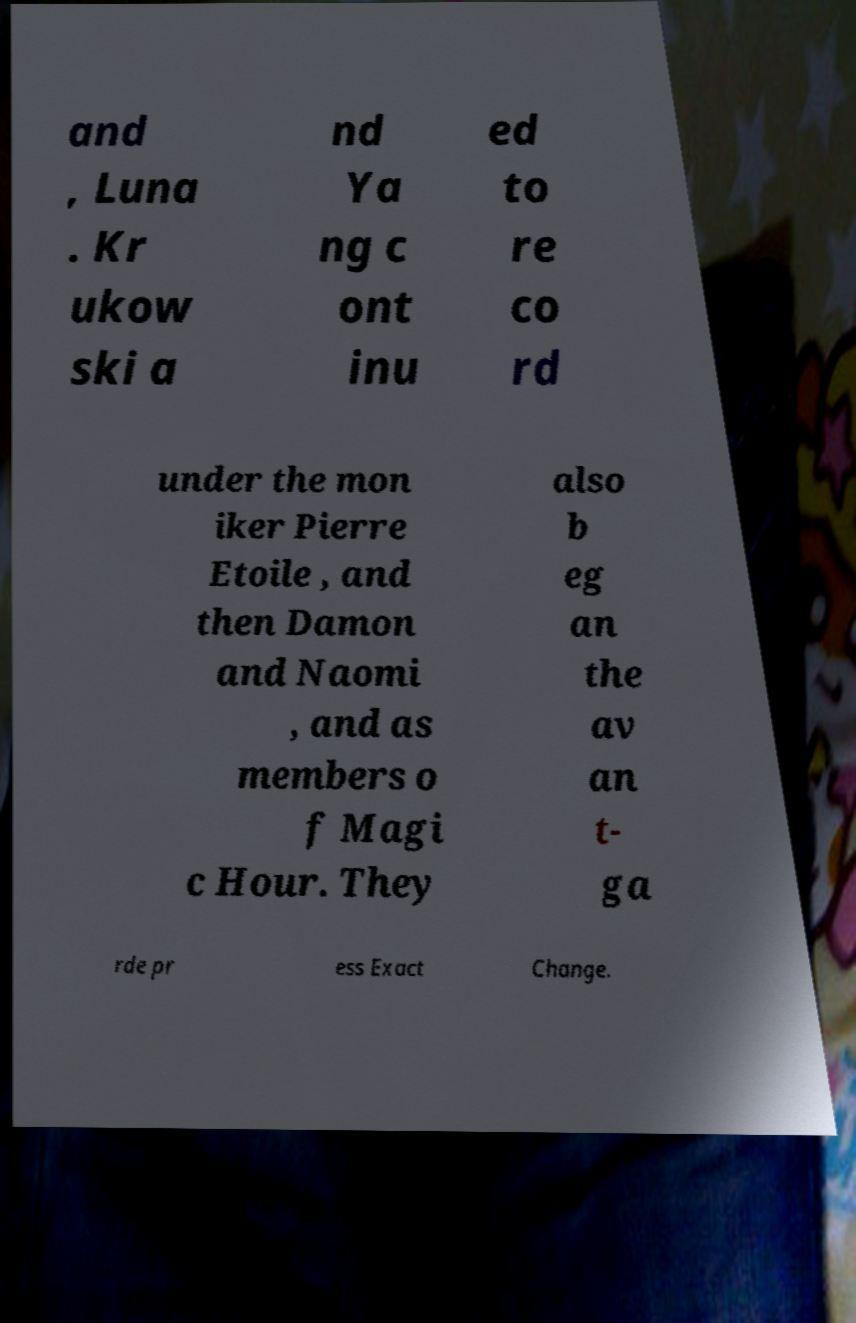Can you read and provide the text displayed in the image?This photo seems to have some interesting text. Can you extract and type it out for me? and , Luna . Kr ukow ski a nd Ya ng c ont inu ed to re co rd under the mon iker Pierre Etoile , and then Damon and Naomi , and as members o f Magi c Hour. They also b eg an the av an t- ga rde pr ess Exact Change. 